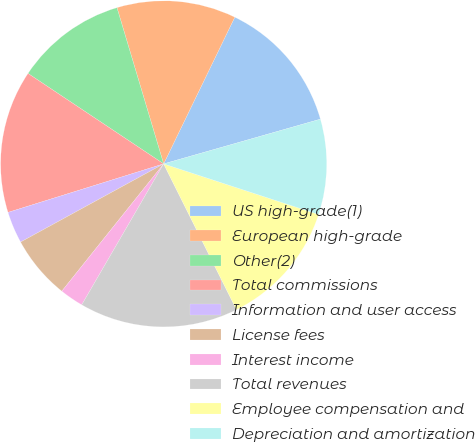Convert chart to OTSL. <chart><loc_0><loc_0><loc_500><loc_500><pie_chart><fcel>US high-grade(1)<fcel>European high-grade<fcel>Other(2)<fcel>Total commissions<fcel>Information and user access<fcel>License fees<fcel>Interest income<fcel>Total revenues<fcel>Employee compensation and<fcel>Depreciation and amortization<nl><fcel>13.39%<fcel>11.81%<fcel>11.02%<fcel>14.17%<fcel>3.15%<fcel>6.3%<fcel>2.36%<fcel>15.75%<fcel>12.6%<fcel>9.45%<nl></chart> 